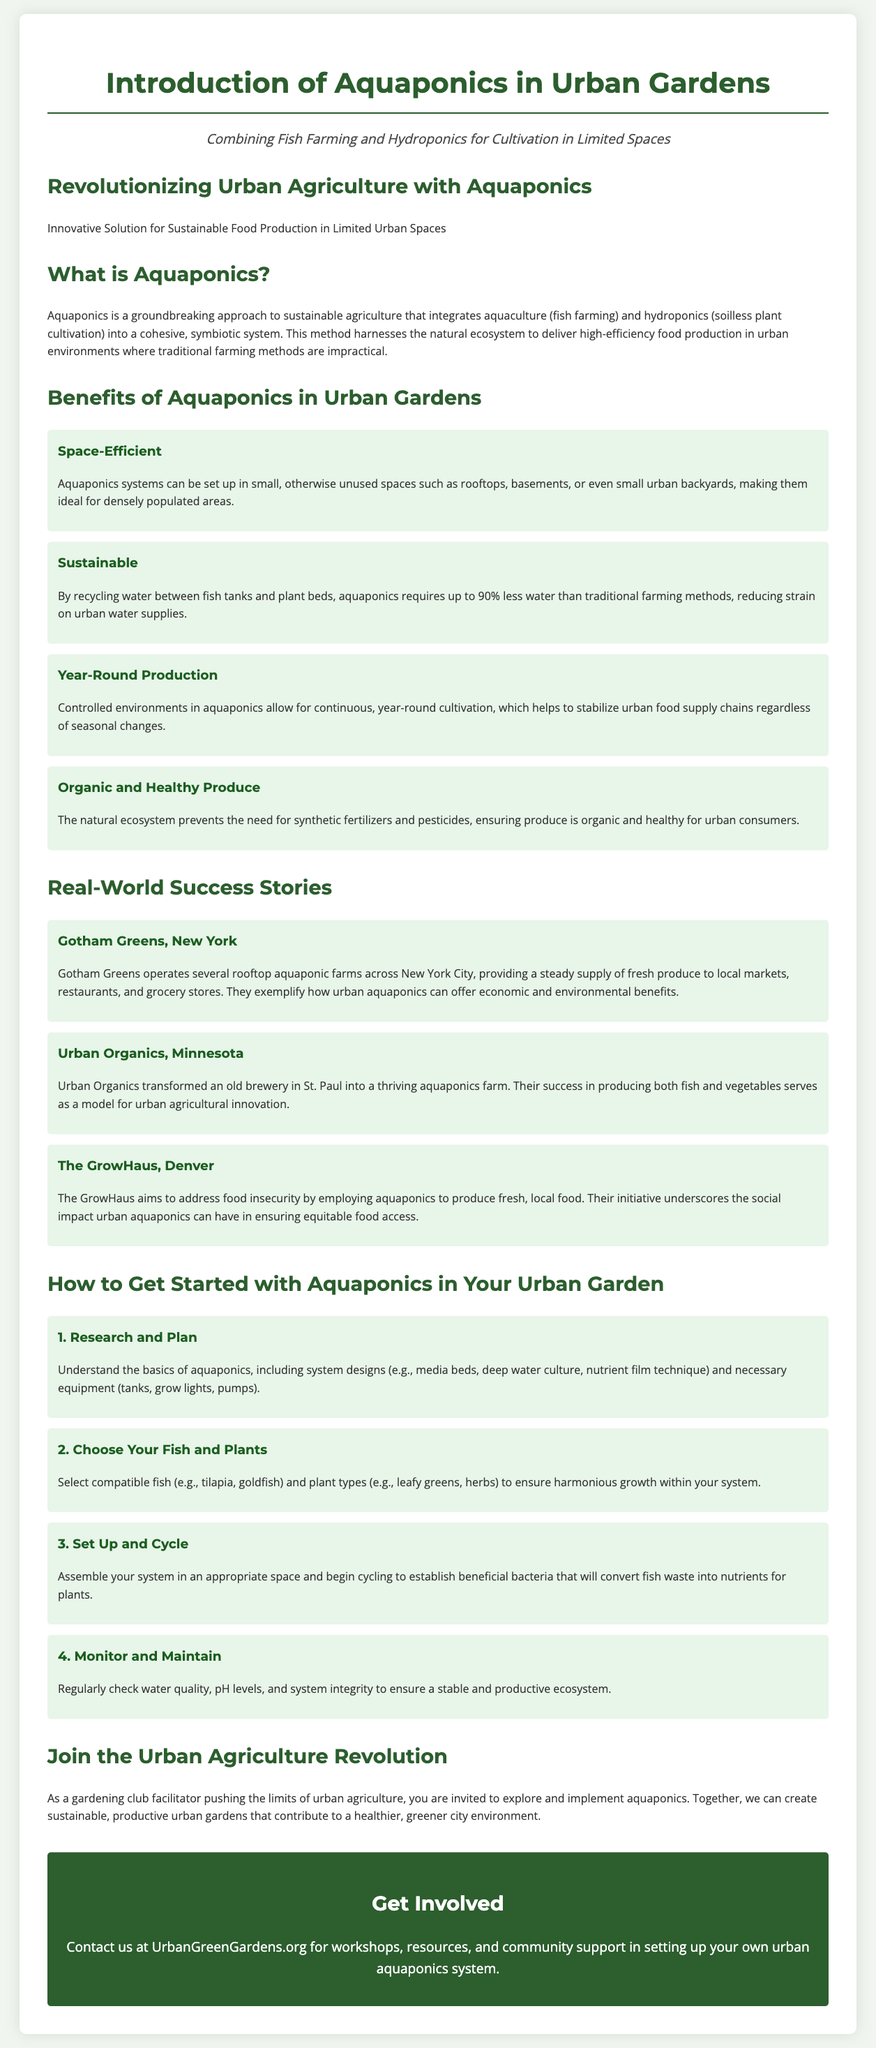What is aquaponics? Aquaponics is a groundbreaking approach to sustainable agriculture that integrates aquaculture and hydroponics into a cohesive, symbiotic system.
Answer: A groundbreaking approach to sustainable agriculture What are two benefits of aquaponics mentioned in the document? The document lists multiple benefits, two of which include being space-efficient and sustainable.
Answer: Space-efficient and sustainable How much less water does aquaponics require compared to traditional farming methods? It states that aquaponics requires up to 90% less water than traditional farming methods.
Answer: 90% less What is the name of the aquaponics farm located in New York City? The document mentions Gotham Greens as an aquaponics farm in New York City.
Answer: Gotham Greens What is the first step in getting started with aquaponics in an urban garden? The first step outlined in the document is "Research and Plan."
Answer: Research and Plan Which fish types are suggested for aquaponics systems? The document suggests tilapia and goldfish as compatible fish for aquaponics systems.
Answer: Tilapia and goldfish What year-round benefit does aquaponics offer for urban food supply chains? The document notes that controlled environments in aquaponics allow for continuous, year-round cultivation.
Answer: Continuous, year-round cultivation What organization can be contacted for workshops on aquaponics? UrbanGreenGardens.org is provided as the contact for workshops and resources.
Answer: UrbanGreenGardens.org 